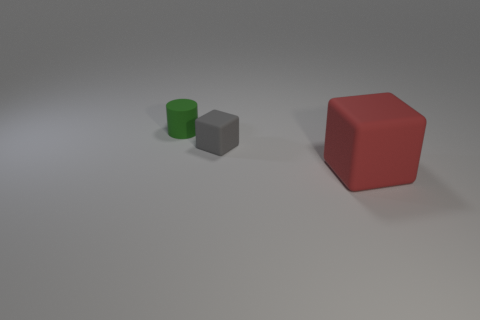What materials do the objects in the image appear to be made of? The objects in the image resemble common geometric solids likely representing materials with matte finishes, suggesting they could be made of some sort of non-reflective plastic or painted wood. 